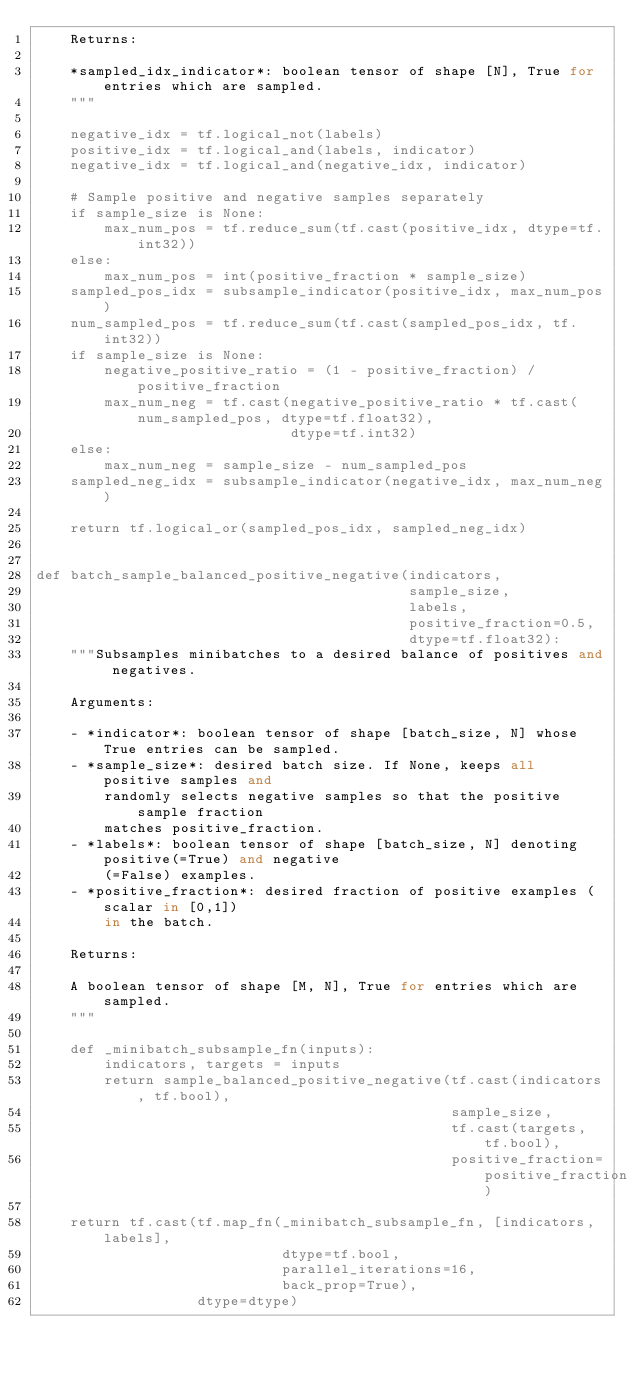<code> <loc_0><loc_0><loc_500><loc_500><_Python_>    Returns:

    *sampled_idx_indicator*: boolean tensor of shape [N], True for entries which are sampled.
    """

    negative_idx = tf.logical_not(labels)
    positive_idx = tf.logical_and(labels, indicator)
    negative_idx = tf.logical_and(negative_idx, indicator)

    # Sample positive and negative samples separately
    if sample_size is None:
        max_num_pos = tf.reduce_sum(tf.cast(positive_idx, dtype=tf.int32))
    else:
        max_num_pos = int(positive_fraction * sample_size)
    sampled_pos_idx = subsample_indicator(positive_idx, max_num_pos)
    num_sampled_pos = tf.reduce_sum(tf.cast(sampled_pos_idx, tf.int32))
    if sample_size is None:
        negative_positive_ratio = (1 - positive_fraction) / positive_fraction
        max_num_neg = tf.cast(negative_positive_ratio * tf.cast(num_sampled_pos, dtype=tf.float32),
                              dtype=tf.int32)
    else:
        max_num_neg = sample_size - num_sampled_pos
    sampled_neg_idx = subsample_indicator(negative_idx, max_num_neg)

    return tf.logical_or(sampled_pos_idx, sampled_neg_idx)


def batch_sample_balanced_positive_negative(indicators,
                                            sample_size,
                                            labels,
                                            positive_fraction=0.5,
                                            dtype=tf.float32):
    """Subsamples minibatches to a desired balance of positives and negatives.

    Arguments:

    - *indicator*: boolean tensor of shape [batch_size, N] whose True entries can be sampled.
    - *sample_size*: desired batch size. If None, keeps all positive samples and
        randomly selects negative samples so that the positive sample fraction
        matches positive_fraction.
    - *labels*: boolean tensor of shape [batch_size, N] denoting positive(=True) and negative
        (=False) examples.
    - *positive_fraction*: desired fraction of positive examples (scalar in [0,1])
        in the batch.

    Returns:

    A boolean tensor of shape [M, N], True for entries which are sampled.
    """

    def _minibatch_subsample_fn(inputs):
        indicators, targets = inputs
        return sample_balanced_positive_negative(tf.cast(indicators, tf.bool),
                                                 sample_size,
                                                 tf.cast(targets, tf.bool),
                                                 positive_fraction=positive_fraction)

    return tf.cast(tf.map_fn(_minibatch_subsample_fn, [indicators, labels],
                             dtype=tf.bool,
                             parallel_iterations=16,
                             back_prop=True),
                   dtype=dtype)
</code> 